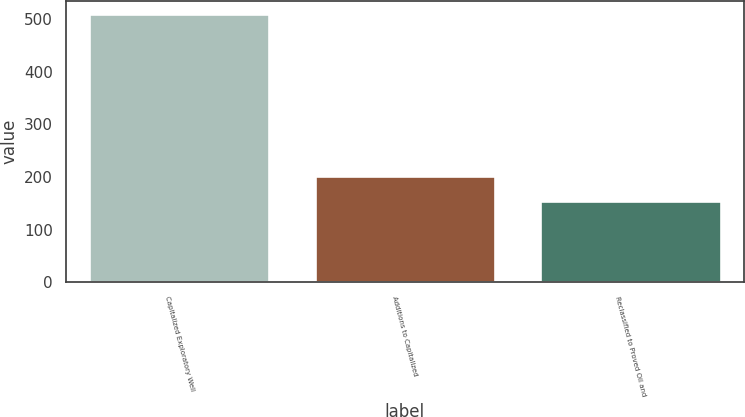Convert chart to OTSL. <chart><loc_0><loc_0><loc_500><loc_500><bar_chart><fcel>Capitalized Exploratory Well<fcel>Additions to Capitalized<fcel>Reclassified to Proved Oil and<nl><fcel>509.3<fcel>201.3<fcel>155<nl></chart> 